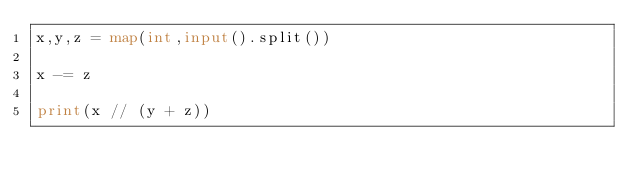Convert code to text. <code><loc_0><loc_0><loc_500><loc_500><_Python_>x,y,z = map(int,input().split())

x -= z

print(x // (y + z))
</code> 